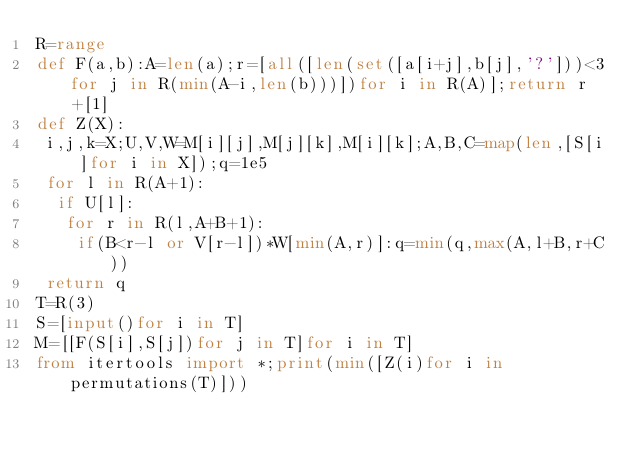<code> <loc_0><loc_0><loc_500><loc_500><_Python_>R=range
def F(a,b):A=len(a);r=[all([len(set([a[i+j],b[j],'?']))<3for j in R(min(A-i,len(b)))])for i in R(A)];return r+[1]
def Z(X):
 i,j,k=X;U,V,W=M[i][j],M[j][k],M[i][k];A,B,C=map(len,[S[i]for i in X]);q=1e5
 for l in R(A+1):
  if U[l]:
   for r in R(l,A+B+1):
    if(B<r-l or V[r-l])*W[min(A,r)]:q=min(q,max(A,l+B,r+C))
 return q
T=R(3)
S=[input()for i in T]
M=[[F(S[i],S[j])for j in T]for i in T]
from itertools import *;print(min([Z(i)for i in permutations(T)]))</code> 